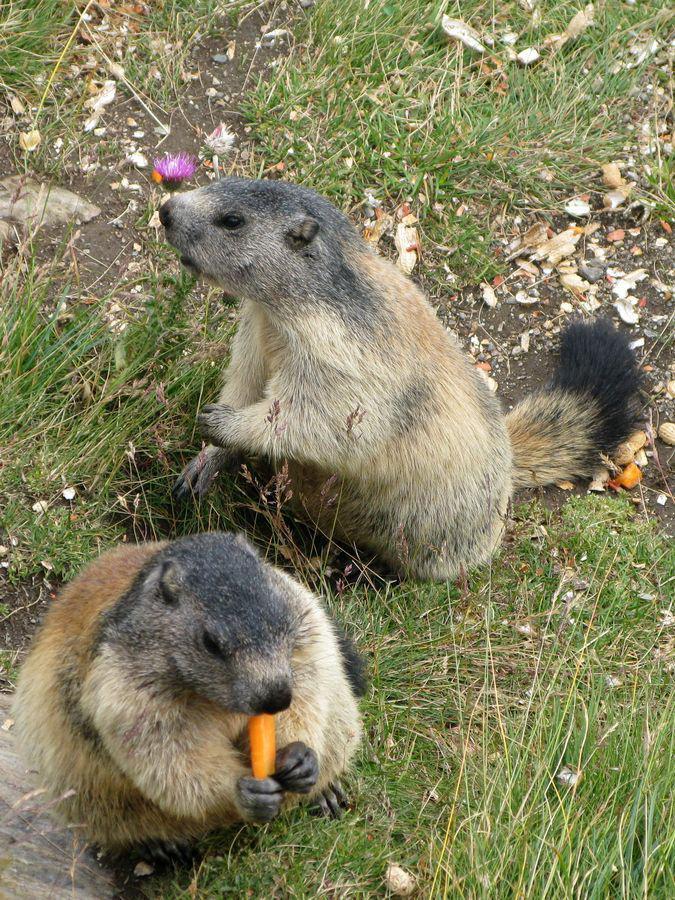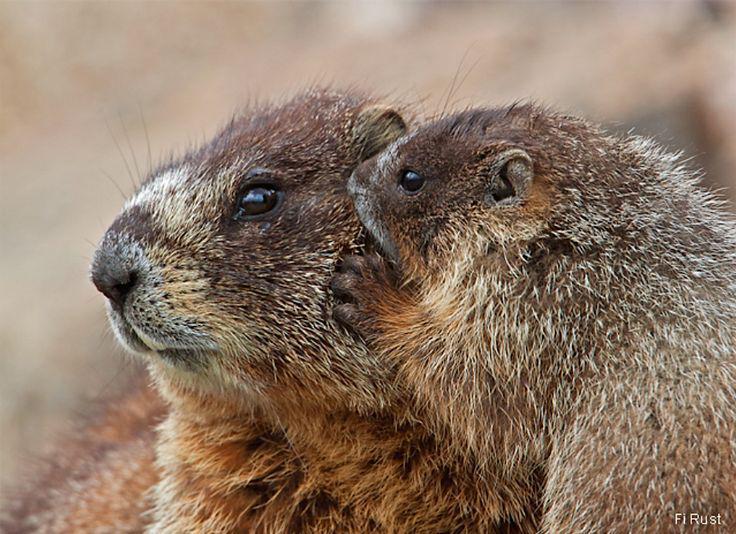The first image is the image on the left, the second image is the image on the right. For the images displayed, is the sentence "At least one image has exactly one animal." factually correct? Answer yes or no. No. The first image is the image on the left, the second image is the image on the right. For the images displayed, is the sentence "In at least one of the images, there is just one marmot" factually correct? Answer yes or no. No. 